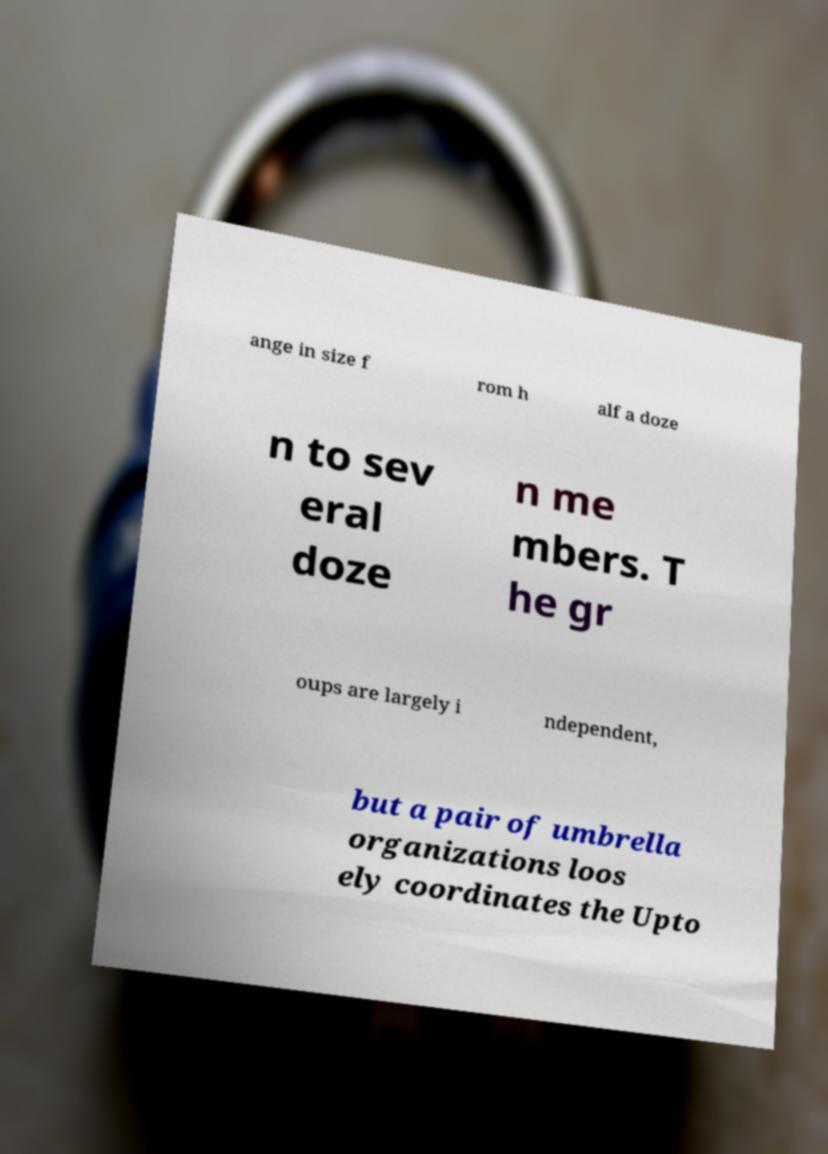Can you accurately transcribe the text from the provided image for me? ange in size f rom h alf a doze n to sev eral doze n me mbers. T he gr oups are largely i ndependent, but a pair of umbrella organizations loos ely coordinates the Upto 